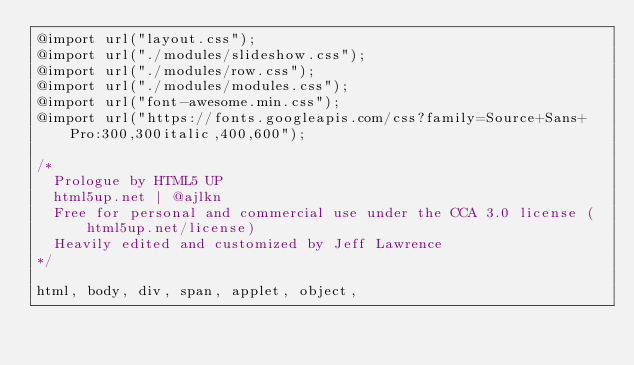<code> <loc_0><loc_0><loc_500><loc_500><_CSS_>@import url("layout.css");
@import url("./modules/slideshow.css");
@import url("./modules/row.css");
@import url("./modules/modules.css");
@import url("font-awesome.min.css");
@import url("https://fonts.googleapis.com/css?family=Source+Sans+Pro:300,300italic,400,600");

/*
	Prologue by HTML5 UP
	html5up.net | @ajlkn
  Free for personal and commercial use under the CCA 3.0 license (html5up.net/license)
  Heavily edited and customized by Jeff Lawrence
*/

html, body, div, span, applet, object,</code> 